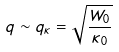Convert formula to latex. <formula><loc_0><loc_0><loc_500><loc_500>q \sim q _ { \kappa } = \sqrt { \frac { W _ { 0 } } { \kappa _ { 0 } } }</formula> 